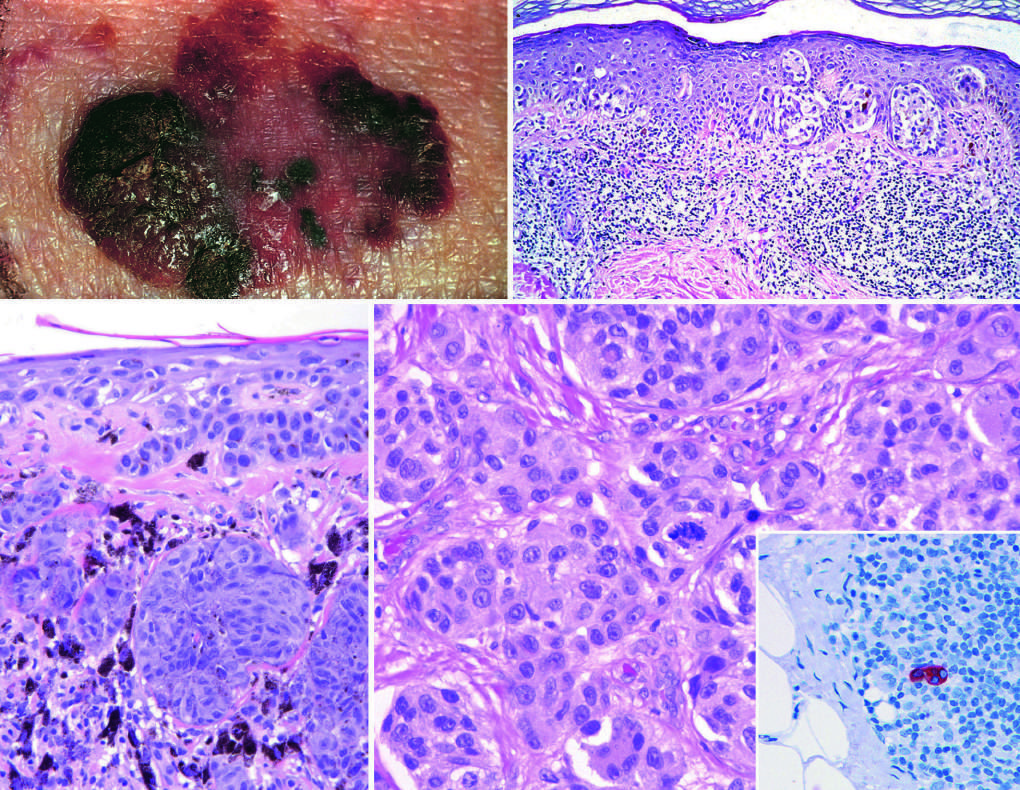do some forms of ftld tend to be larger than nevi, with irregular contours and variable pigmentation?
Answer the question using a single word or phrase. No 